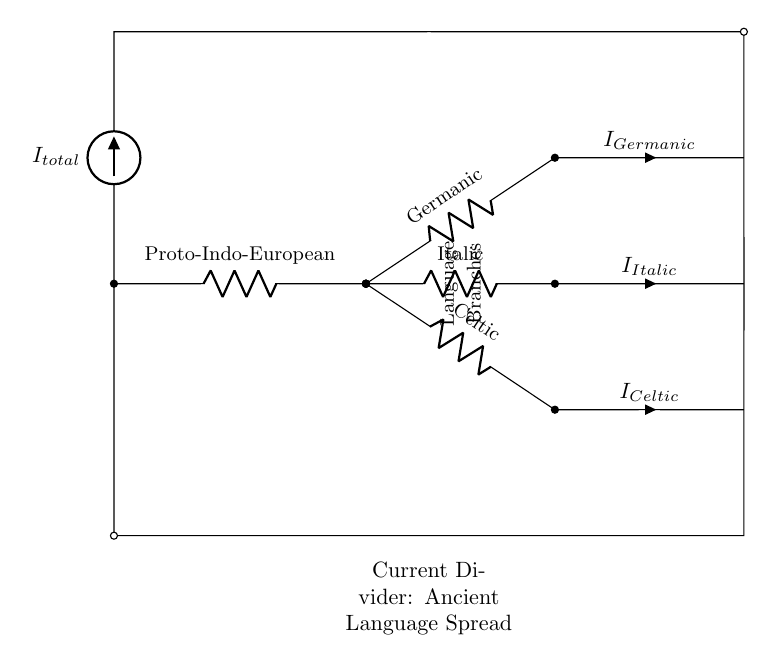What is the total current flowing in this circuit? The total current, labeled as I_total in the diagram, represents the aggregate flow entering the circuit. It is the source of all subsequent branches and is found at the top.
Answer: I_total What are the three language branches depicted in the circuit? The branches representing the languages are Proto-Indo-European, Germanic, Italic, and Celtic. Each branch is shown as a resistor in the diagram.
Answer: Germanic, Italic, Celtic Which branch corresponds to the current labeled I_Germanic? The I_Germanic current flows through the branch marked Germanic. This branch connects from Proto-Indo-European and is identified by its respective label in the circuit.
Answer: Germanic How many branches are there in the current divider? A careful observation shows three branches that split from the main line after Proto-Indo-European, indicating the presence of multiple paths for current flow.
Answer: Three What role does the Proto-Indo-European play in this circuit diagram? Proto-Indo-European serves as the source from which all language branches diverge. It acts as the initial point of current (or language influence) distribution.
Answer: Source What is the significance of the short lines leading to the current labels (I_Germanic, I_Italic, I_Celtic)? The short lines show where the current exits each branch after passing through the resistors, indicating how language influences diverge from the Proto-Indo-European source to various branches.
Answer: Current exits If the total current is 10A, how would it be divided among the branches? To find out how the total current divides, one would look at the resistance values of each branch, which affects the current distribution according to Ohm's law. Each branch may receive a different amount of current based on its resistance.
Answer: Depends on resistance 